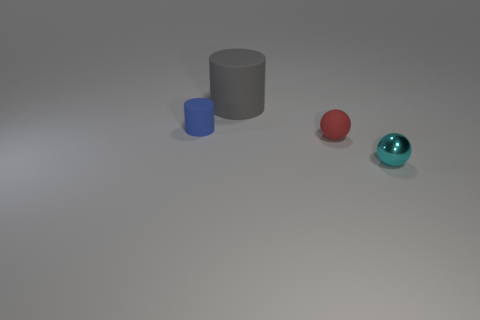There is a tiny object that is to the left of the ball that is left of the thing right of the red object; what is its shape?
Offer a very short reply. Cylinder. There is a rubber object to the right of the gray matte thing on the left side of the small sphere behind the metal thing; what is its color?
Provide a short and direct response. Red. What color is the large object that is the same shape as the tiny blue rubber thing?
Ensure brevity in your answer.  Gray. How many other things are made of the same material as the tiny red thing?
Keep it short and to the point. 2. Is there a tiny brown shiny object that has the same shape as the small blue thing?
Provide a short and direct response. No. How many objects are either tiny purple matte cylinders or tiny things that are right of the tiny red ball?
Your answer should be very brief. 1. There is a tiny sphere to the right of the small red sphere; what color is it?
Ensure brevity in your answer.  Cyan. Is the size of the rubber thing that is behind the blue thing the same as the rubber object that is in front of the small blue thing?
Give a very brief answer. No. Is there a blue matte object of the same size as the cyan metallic ball?
Keep it short and to the point. Yes. There is a cylinder in front of the gray matte cylinder; what number of small red rubber balls are behind it?
Keep it short and to the point. 0. 